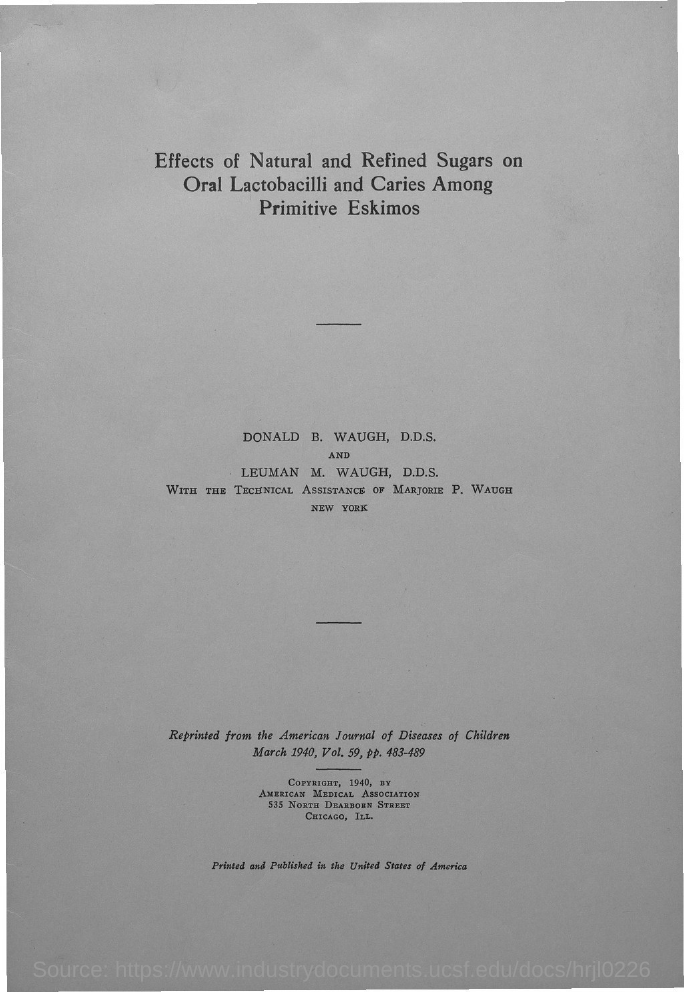What is the title?
Give a very brief answer. Effects of natural and refined sugars on oral lactobacilli and caries among primitive eskimos. Who provided the technical assistance?
Offer a very short reply. Marjorie P. Waugh. From which Journal is it reprinted from?
Make the answer very short. American Journal of Diseases of Children. Which year it was published?
Make the answer very short. 1940. What is the volume number of the journal?
Your answer should be compact. Vol. 59. Who owns the copyright?
Give a very brief answer. American Medical Association. Where was it printed and published?
Your answer should be very brief. The united states of America. 